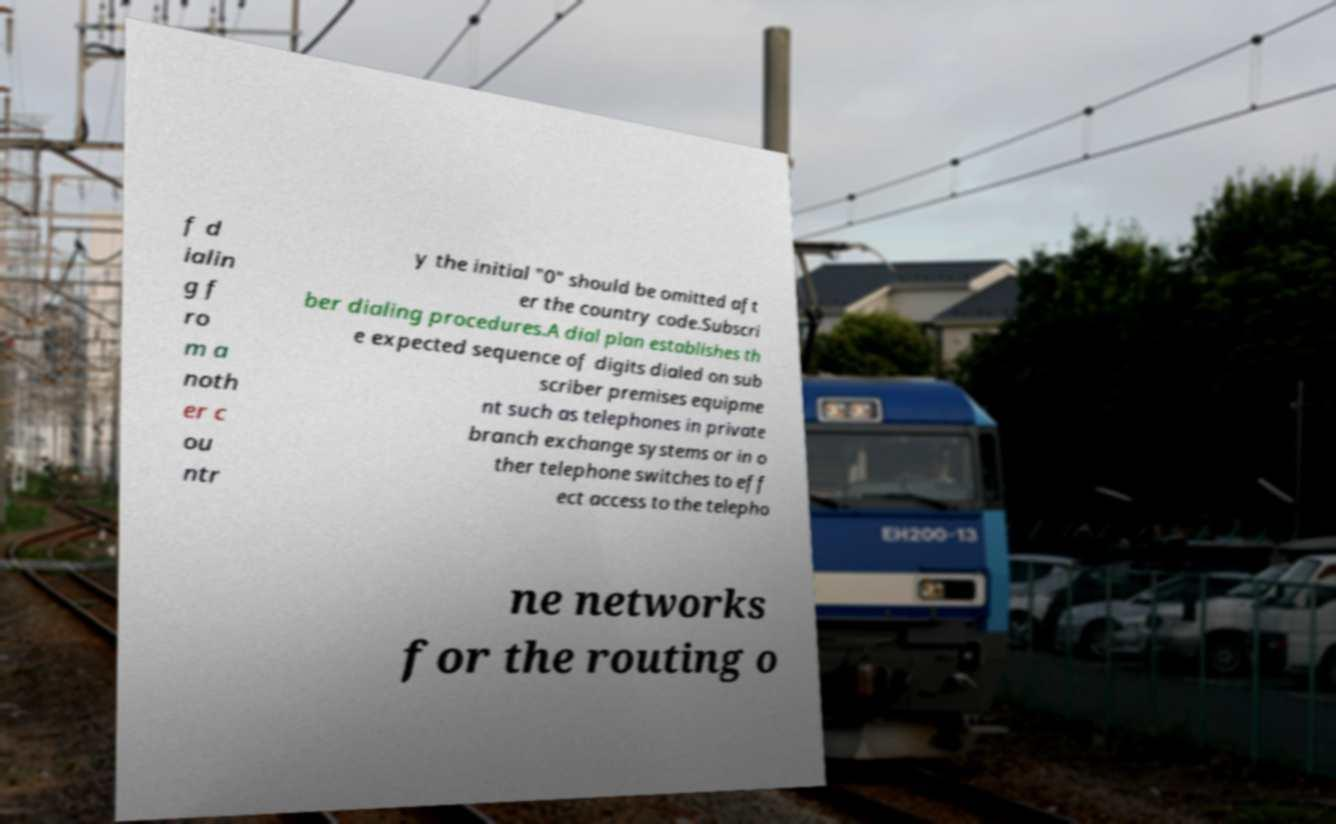Can you accurately transcribe the text from the provided image for me? f d ialin g f ro m a noth er c ou ntr y the initial "0" should be omitted aft er the country code.Subscri ber dialing procedures.A dial plan establishes th e expected sequence of digits dialed on sub scriber premises equipme nt such as telephones in private branch exchange systems or in o ther telephone switches to eff ect access to the telepho ne networks for the routing o 